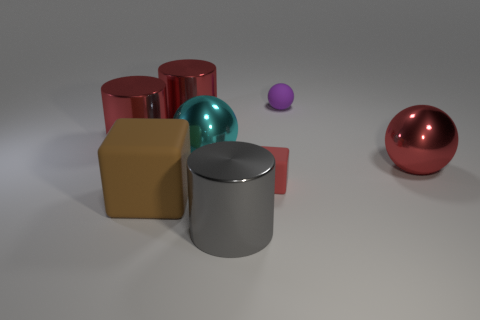There is a big object that is in front of the red shiny ball and to the left of the large gray metallic object; what color is it?
Your response must be concise. Brown. Does the gray cylinder have the same material as the block that is on the right side of the big brown rubber thing?
Provide a succinct answer. No. Are there fewer purple spheres behind the red sphere than red metallic things?
Keep it short and to the point. Yes. What number of other things are there of the same shape as the big matte thing?
Give a very brief answer. 1. Is there any other thing that is the same color as the small matte block?
Your answer should be very brief. Yes. Do the small cube and the big thing that is on the right side of the tiny red matte cube have the same color?
Give a very brief answer. Yes. How many other things are there of the same size as the brown thing?
Offer a terse response. 5. What size is the metal sphere that is the same color as the small block?
Your answer should be very brief. Large. How many cubes are either big gray things or cyan shiny things?
Keep it short and to the point. 0. Does the thing in front of the brown thing have the same shape as the cyan thing?
Offer a very short reply. No. 